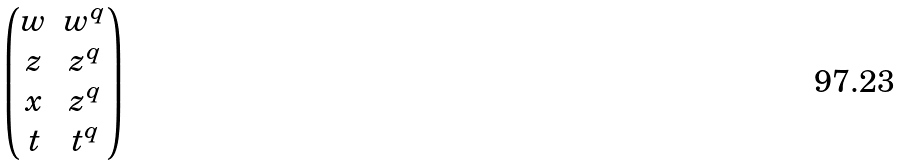<formula> <loc_0><loc_0><loc_500><loc_500>\begin{pmatrix} w & w ^ { q } \\ z & z ^ { q } \\ x & z ^ { q } \\ t & t ^ { q } \end{pmatrix}</formula> 